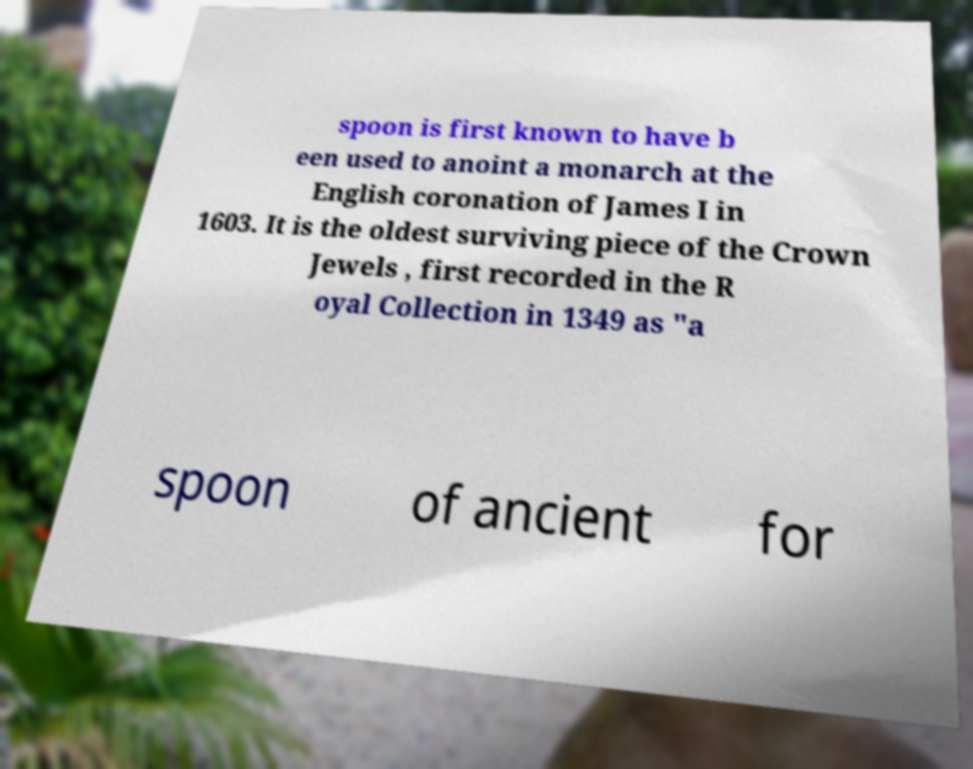There's text embedded in this image that I need extracted. Can you transcribe it verbatim? spoon is first known to have b een used to anoint a monarch at the English coronation of James I in 1603. It is the oldest surviving piece of the Crown Jewels , first recorded in the R oyal Collection in 1349 as "a spoon of ancient for 